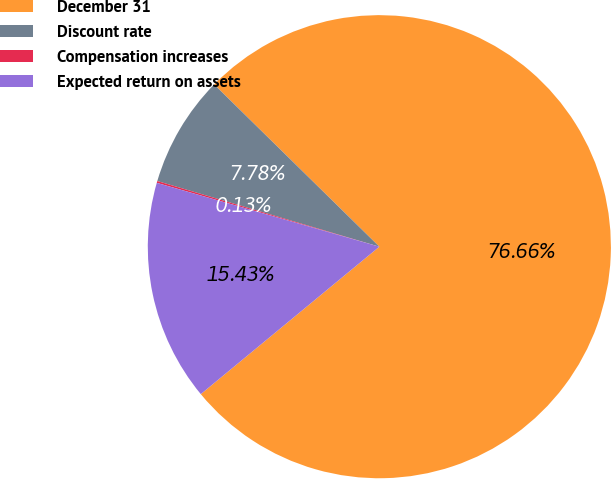<chart> <loc_0><loc_0><loc_500><loc_500><pie_chart><fcel>December 31<fcel>Discount rate<fcel>Compensation increases<fcel>Expected return on assets<nl><fcel>76.66%<fcel>7.78%<fcel>0.13%<fcel>15.43%<nl></chart> 